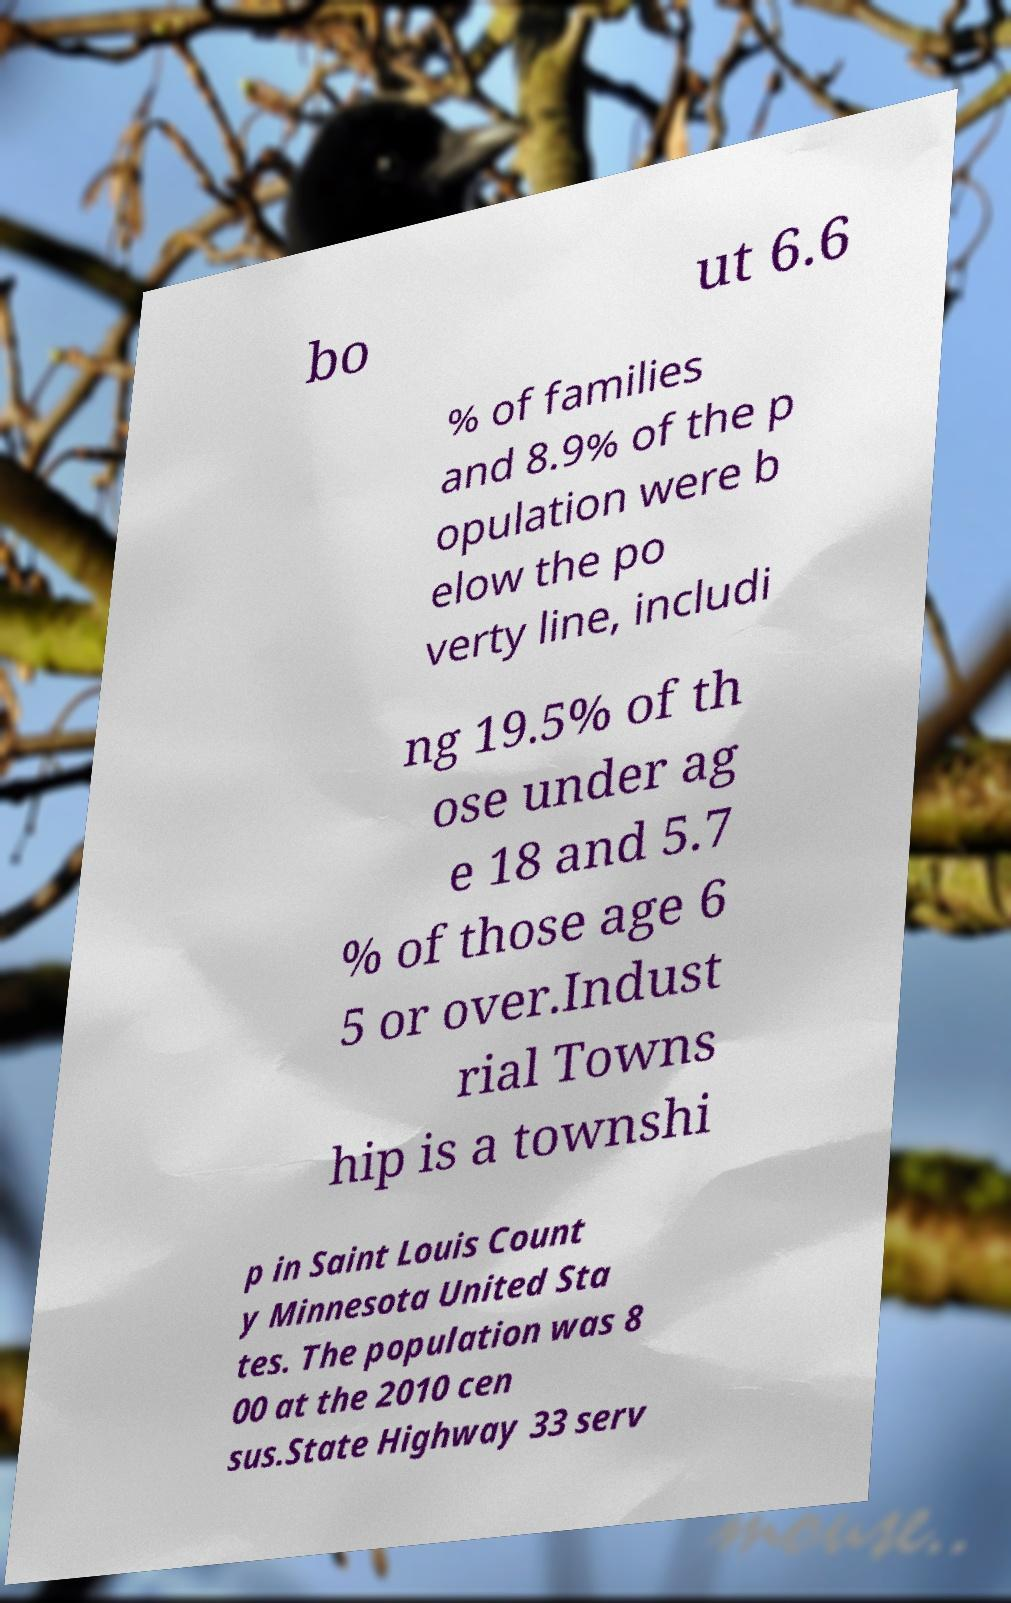Can you read and provide the text displayed in the image?This photo seems to have some interesting text. Can you extract and type it out for me? bo ut 6.6 % of families and 8.9% of the p opulation were b elow the po verty line, includi ng 19.5% of th ose under ag e 18 and 5.7 % of those age 6 5 or over.Indust rial Towns hip is a townshi p in Saint Louis Count y Minnesota United Sta tes. The population was 8 00 at the 2010 cen sus.State Highway 33 serv 